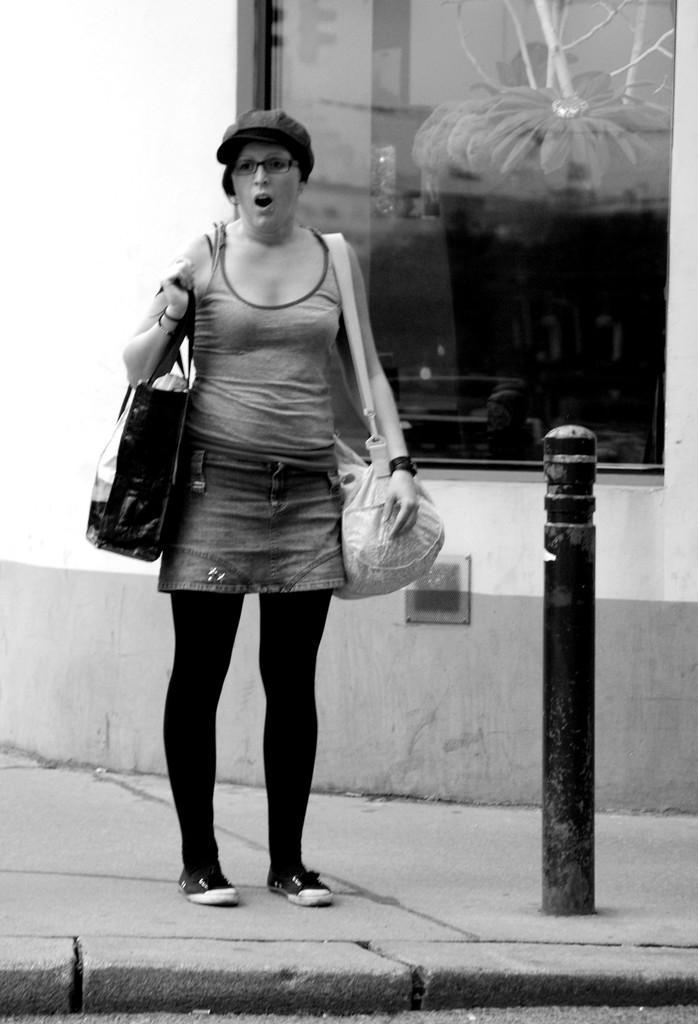Describe this image in one or two sentences. In this image I can see a woman is standing on the footpath by holding the two bags, on the right side there is the glass wall, this image is in black and white color. 